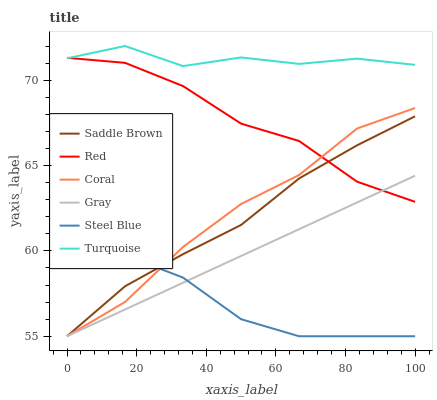Does Steel Blue have the minimum area under the curve?
Answer yes or no. Yes. Does Turquoise have the maximum area under the curve?
Answer yes or no. Yes. Does Coral have the minimum area under the curve?
Answer yes or no. No. Does Coral have the maximum area under the curve?
Answer yes or no. No. Is Gray the smoothest?
Answer yes or no. Yes. Is Turquoise the roughest?
Answer yes or no. Yes. Is Coral the smoothest?
Answer yes or no. No. Is Coral the roughest?
Answer yes or no. No. Does Gray have the lowest value?
Answer yes or no. Yes. Does Turquoise have the lowest value?
Answer yes or no. No. Does Turquoise have the highest value?
Answer yes or no. Yes. Does Coral have the highest value?
Answer yes or no. No. Is Coral less than Turquoise?
Answer yes or no. Yes. Is Turquoise greater than Gray?
Answer yes or no. Yes. Does Red intersect Turquoise?
Answer yes or no. Yes. Is Red less than Turquoise?
Answer yes or no. No. Is Red greater than Turquoise?
Answer yes or no. No. Does Coral intersect Turquoise?
Answer yes or no. No. 